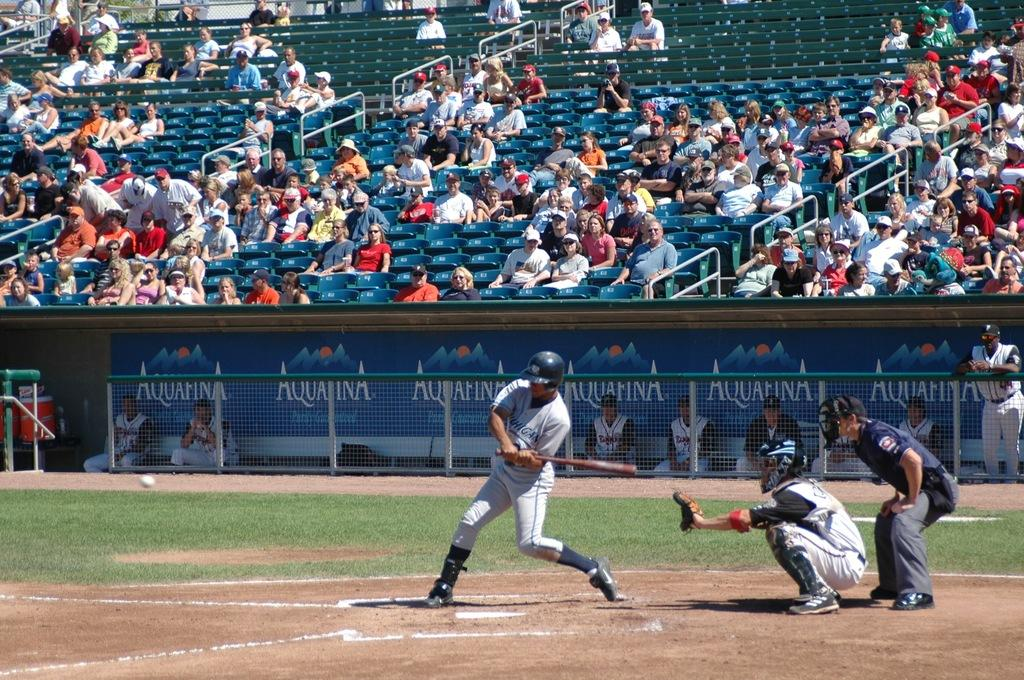<image>
Describe the image concisely. a baseball player is getting ready to swing his bat with an aquafina logo in the dugout. 